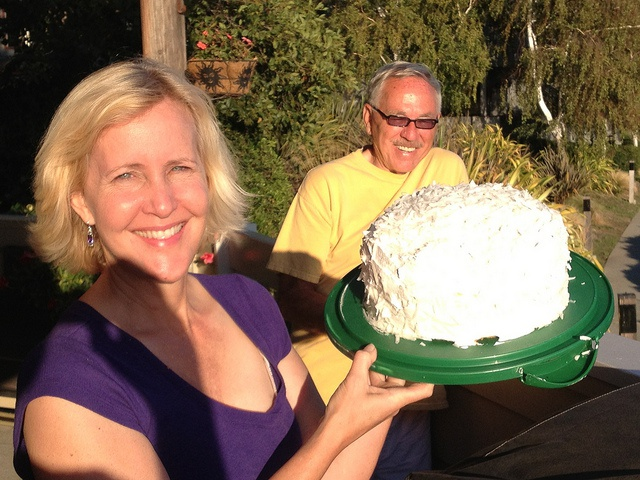Describe the objects in this image and their specific colors. I can see people in black, salmon, tan, and purple tones, cake in black, ivory, and tan tones, and people in black, khaki, and salmon tones in this image. 